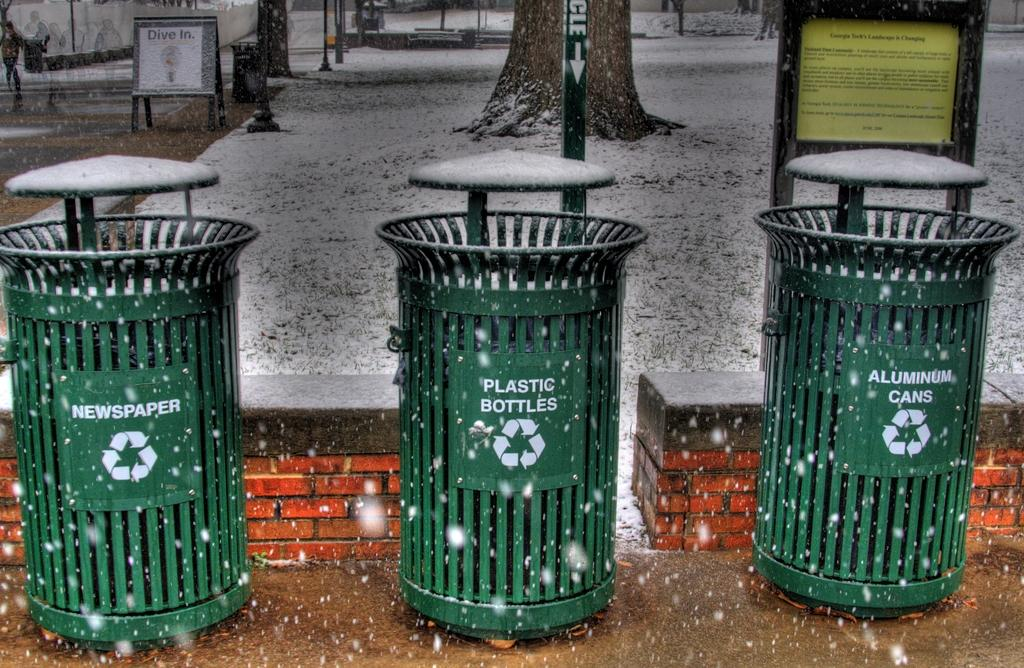<image>
Provide a brief description of the given image. Three garbage bins, one for newspaper, one for plastic bottles and the last for aluminum cans. 